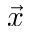Convert formula to latex. <formula><loc_0><loc_0><loc_500><loc_500>\vec { x }</formula> 